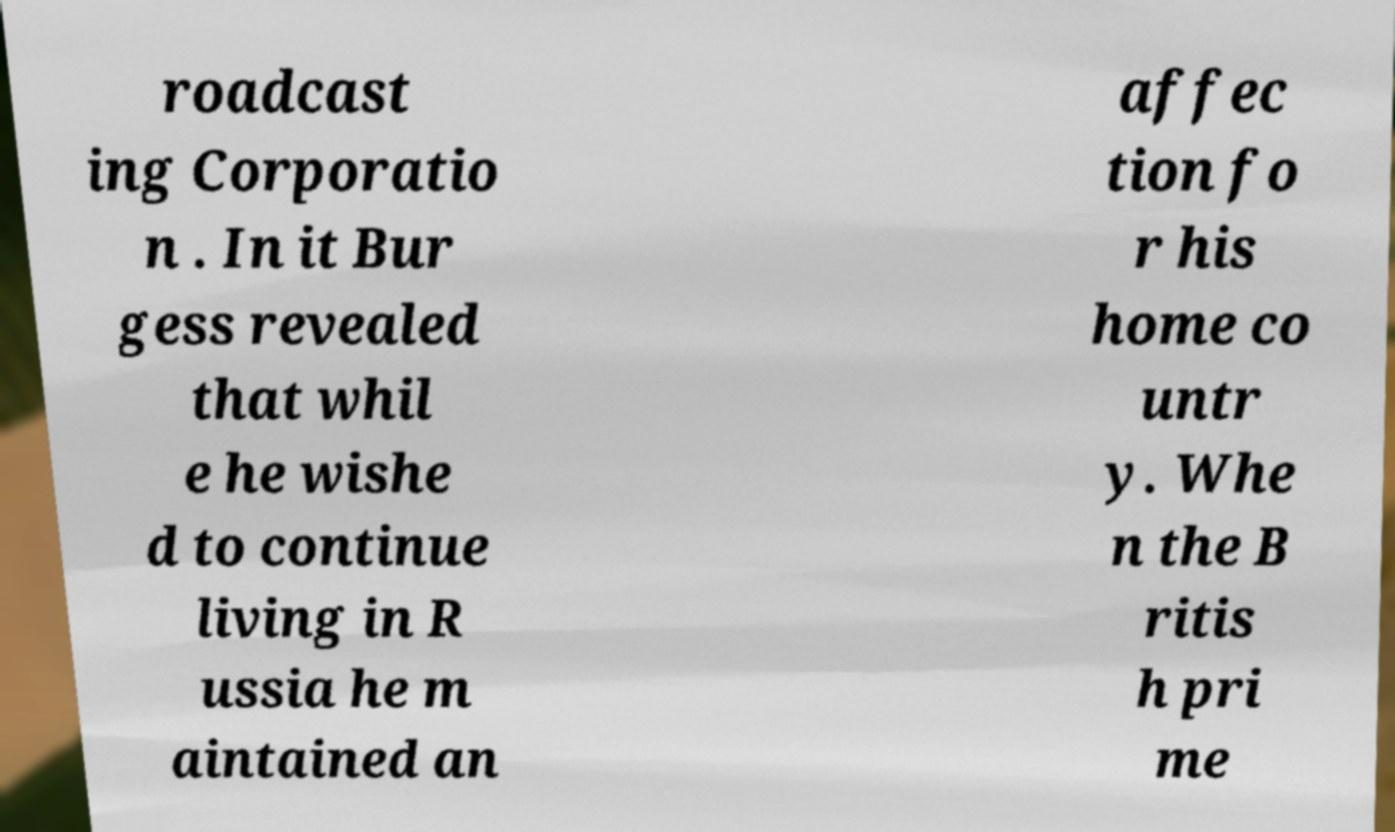What messages or text are displayed in this image? I need them in a readable, typed format. roadcast ing Corporatio n . In it Bur gess revealed that whil e he wishe d to continue living in R ussia he m aintained an affec tion fo r his home co untr y. Whe n the B ritis h pri me 